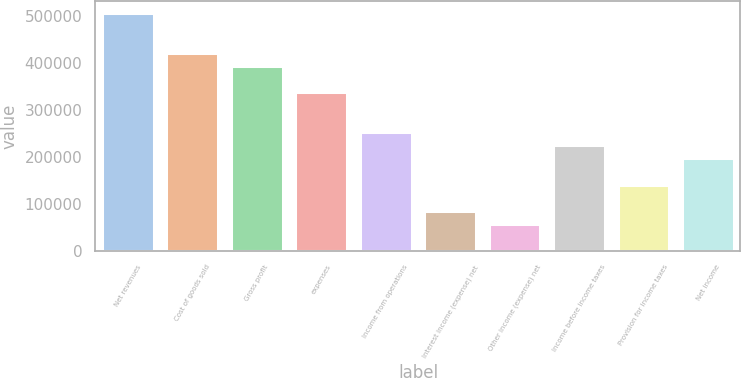Convert chart to OTSL. <chart><loc_0><loc_0><loc_500><loc_500><bar_chart><fcel>Net revenues<fcel>Cost of goods sold<fcel>Gross profit<fcel>expenses<fcel>Income from operations<fcel>Interest income (expense) net<fcel>Other income (expense) net<fcel>Income before income taxes<fcel>Provision for income taxes<fcel>Net income<nl><fcel>505895<fcel>421579<fcel>393474<fcel>337263<fcel>252948<fcel>84316.1<fcel>56210.9<fcel>224842<fcel>140527<fcel>196737<nl></chart> 